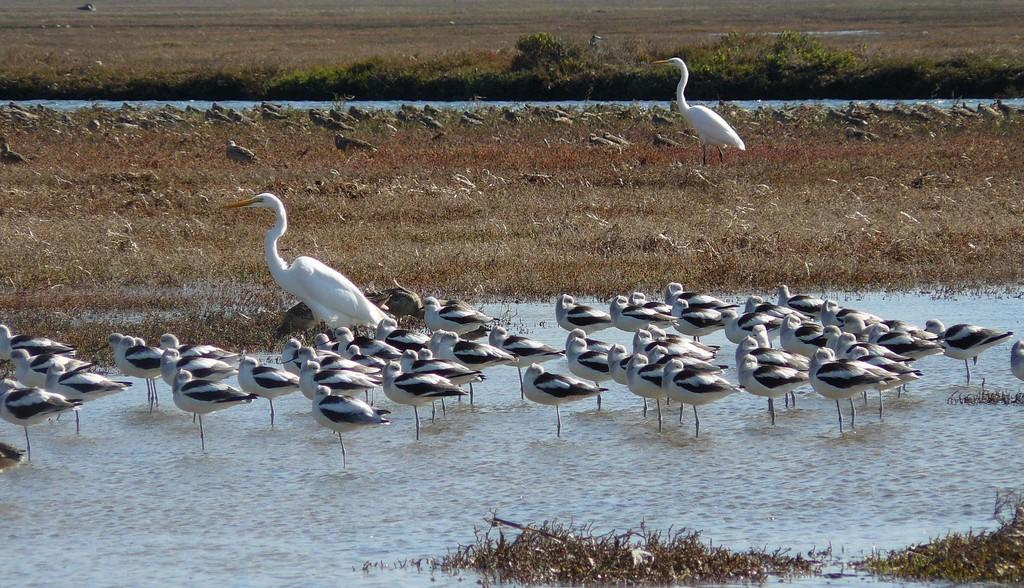What animals are present in the image? There are many swans in the image. What is the primary setting for the swans in the image? There is water visible at the bottom of the image. What objects can be seen in the water? There are twigs in the water. What type of vegetation is behind the swans? There is grass behind the swans. What can be seen in the distance in the image? There are trees in the background of the image. What type of lead can be seen in the image? There is no lead present in the image. Can you tell me how many grapes are visible in the image? There are no grapes visible in the image. 